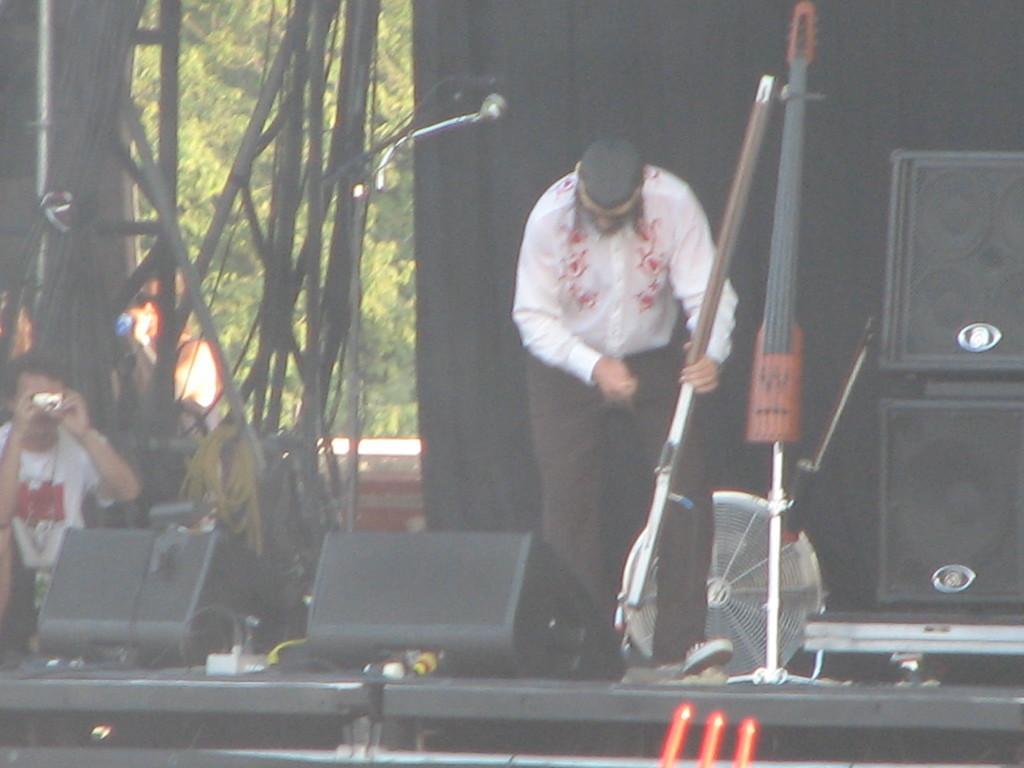How would you summarize this image in a sentence or two? Here I can see a man standing on the stage and holding an object in the hands. At the back of this man there is a fan. On the right side, I can see the speakers. In the background there is a black color curtain. On the left side, I can see a man is sitting and capturing the picture by holding camera in the hands. In the background, I can see some sticks and trees. 